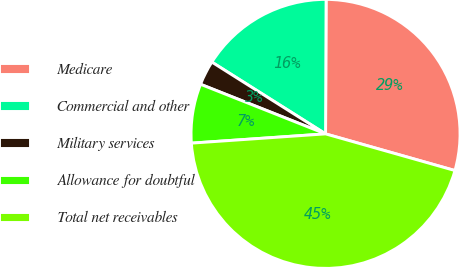Convert chart. <chart><loc_0><loc_0><loc_500><loc_500><pie_chart><fcel>Medicare<fcel>Commercial and other<fcel>Military services<fcel>Allowance for doubtful<fcel>Total net receivables<nl><fcel>29.33%<fcel>16.1%<fcel>2.95%<fcel>7.11%<fcel>44.51%<nl></chart> 